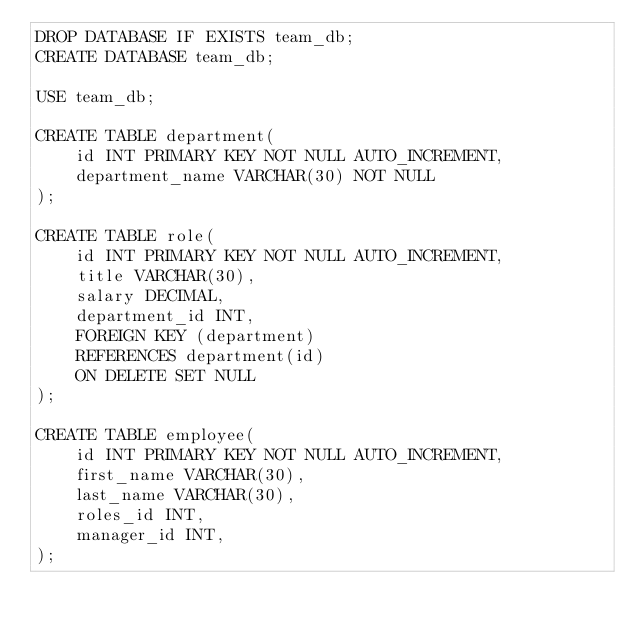Convert code to text. <code><loc_0><loc_0><loc_500><loc_500><_SQL_>DROP DATABASE IF EXISTS team_db;
CREATE DATABASE team_db;

USE team_db;

CREATE TABLE department(
    id INT PRIMARY KEY NOT NULL AUTO_INCREMENT,
    department_name VARCHAR(30) NOT NULL
);

CREATE TABLE role(
    id INT PRIMARY KEY NOT NULL AUTO_INCREMENT,
    title VARCHAR(30),
    salary DECIMAL,
    department_id INT,
    FOREIGN KEY (department)
    REFERENCES department(id)
    ON DELETE SET NULL
);

CREATE TABLE employee(
    id INT PRIMARY KEY NOT NULL AUTO_INCREMENT,
    first_name VARCHAR(30),
    last_name VARCHAR(30),
    roles_id INT,
    manager_id INT,
);</code> 